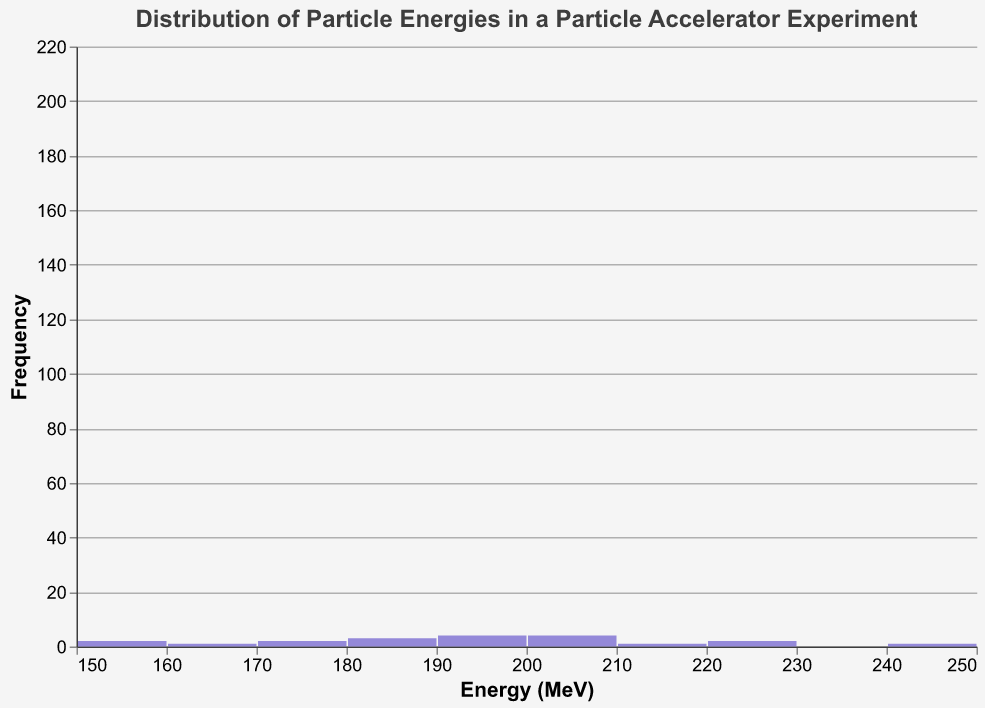What is the title of the plot? The title is located at the top of the chart. From the visual, it's clear that the title reads "Distribution of Particle Energies in a Particle Accelerator Experiment."
Answer: Distribution of Particle Energies in a Particle Accelerator Experiment How many total data points (particles) are represented in the figure? The histogram bars on the x-axis, when summed by their counts on the y-axis, indicate the total number of particles. This total count is 20.
Answer: 20 Which particle has the highest energy? The highest energy value can be observed on the histogram bar furthest to the right. From the visual, it corresponds to "Higgs_Boson" at 250 MeV.
Answer: Higgs_Boson What is the range of energies shown in the figure? The x-axis indicates the energy range of the particles. The lowest bin starts just below 150 MeV and the highest around 250 MeV. Hence, the energy range is from approximately 150 MeV to 250 MeV.
Answer: 150 MeV to 250 MeV Which energy bin contains the highest frequency of particles? By examining the height of the bars on the y-axis, the bin with the highest frequency appears around 195-200 MeV.
Answer: 195-200 MeV How does the frequency distribution change as energy levels increase? Observing the histogram, the frequency increases initially toward the middle energy ranges and then tends to decrease as energy moves towards higher values.
Answer: Increases at first, then decreases What is the color used for the line graph overlay on the histogram? The line graph overlay color can be noted visually. The line is colored orange.
Answer: Orange How many energy bins are used in the histogram? The exact number of bins can be observed by counting the grouped bars along the x-axis. There are 15 bins in total.
Answer: 15 What is the most common energy level or mode in the histogram? The mode corresponds to the highest frequency bin. The histogram shows the peak at the energy level around 195-200 MeV.
Answer: Around 195-200 MeV How does the particle count trend for energies above 200 MeV? From the histogram, it can be seen that the particle count trends downward as energy levels increase beyond 200 MeV.
Answer: Decreases 